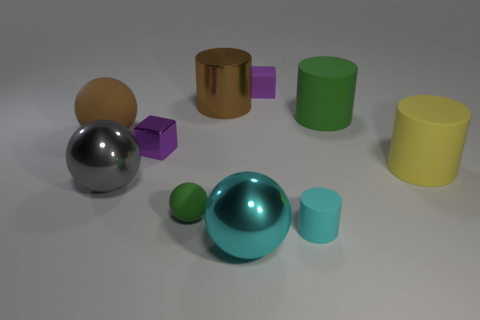The purple metallic object is what shape?
Provide a short and direct response. Cube. How many gray objects have the same material as the green sphere?
Make the answer very short. 0. There is a tiny rubber block; is its color the same as the tiny sphere on the right side of the purple shiny thing?
Your response must be concise. No. How many brown rubber things are there?
Provide a succinct answer. 1. Is there a big metal sphere that has the same color as the small shiny object?
Your answer should be very brief. No. There is a cylinder in front of the small green rubber thing on the left side of the small purple object on the right side of the brown metal cylinder; what color is it?
Your response must be concise. Cyan. Is the material of the brown cylinder the same as the big thing in front of the big gray metallic sphere?
Provide a succinct answer. Yes. What is the material of the gray sphere?
Your response must be concise. Metal. What is the material of the big thing that is the same color as the large matte ball?
Your answer should be compact. Metal. How many other objects are there of the same material as the small cylinder?
Your answer should be compact. 5. 